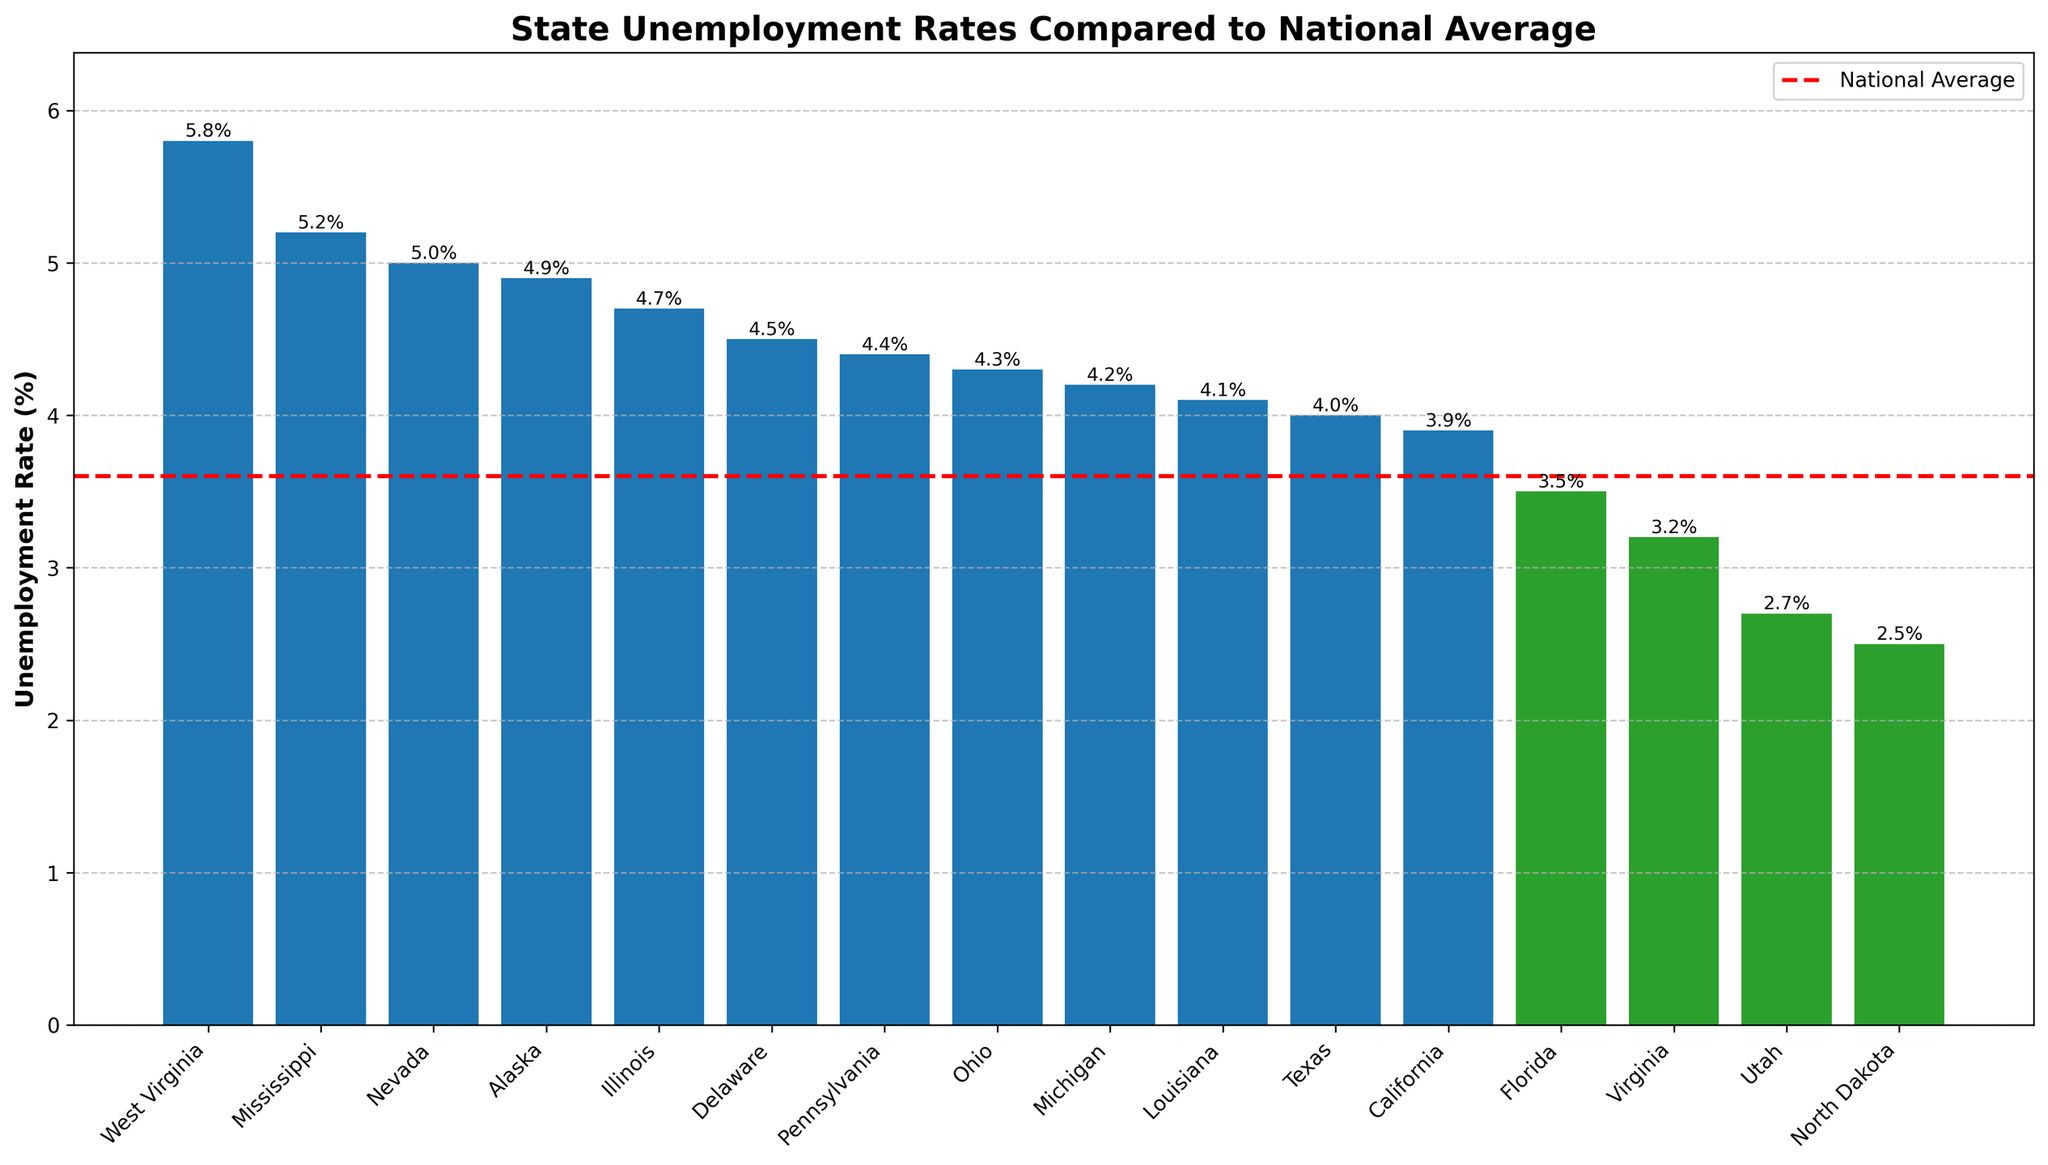What state has the highest unemployment rate? The highest bar represents the state with the highest unemployment rate. West Virginia has the highest bar at 5.8%.
Answer: West Virginia How many states have unemployment rates above the national average? Count the number of bars that are taller than the national average line. There are 11 bars above the national average of 3.6%.
Answer: 11 Which state has the lowest unemployment rate? The shortest bar represents the state with the lowest unemployment rate. North Dakota has the shortest bar at 2.5%.
Answer: North Dakota Which states have unemployment rates below the national average? These states correspond to bars that are shorter than the national average line. The states below the national average are Florida, Virginia, Utah, and North Dakota.
Answer: Florida, Virginia, Utah, North Dakota What is the difference in unemployment rates between West Virginia and Utah? Subtract Utah's rate from West Virginia's rate. West Virginia has 5.8% and Utah has 2.7%, so the difference is 5.8% - 2.7% = 3.1%.
Answer: 3.1% Are there more states with unemployment rates above or below the national average? Compare the number of states with rates above and below the national average. 11 states are above, and 4 are below, so there are more states above the national average.
Answer: Above Which state is closest to the national average in terms of unemployment rate? Look for the bar that is closest in height to the national average line. California has an unemployment rate of 3.9%, closest to the national average of 3.6%.
Answer: California Which state has an unemployment rate exactly equal to the national average? Identify any bar that aligns exactly with the national average line. Florida's bar aligns with the national average of 3.6%.
Answer: Florida What is the combined unemployment rate for West Virginia and Mississippi? Add the unemployment rates of both states. West Virginia has 5.8% and Mississippi has 5.2%, so the combined rate is 5.8% + 5.2% = 11.0%.
Answer: 11.0% Which state has a higher unemployment rate, Texas or California? Compare the heights of the bars for Texas and California. Texas is at 4.0%, and California is at 3.9%. Therefore, Texas has a higher unemployment rate.
Answer: Texas 